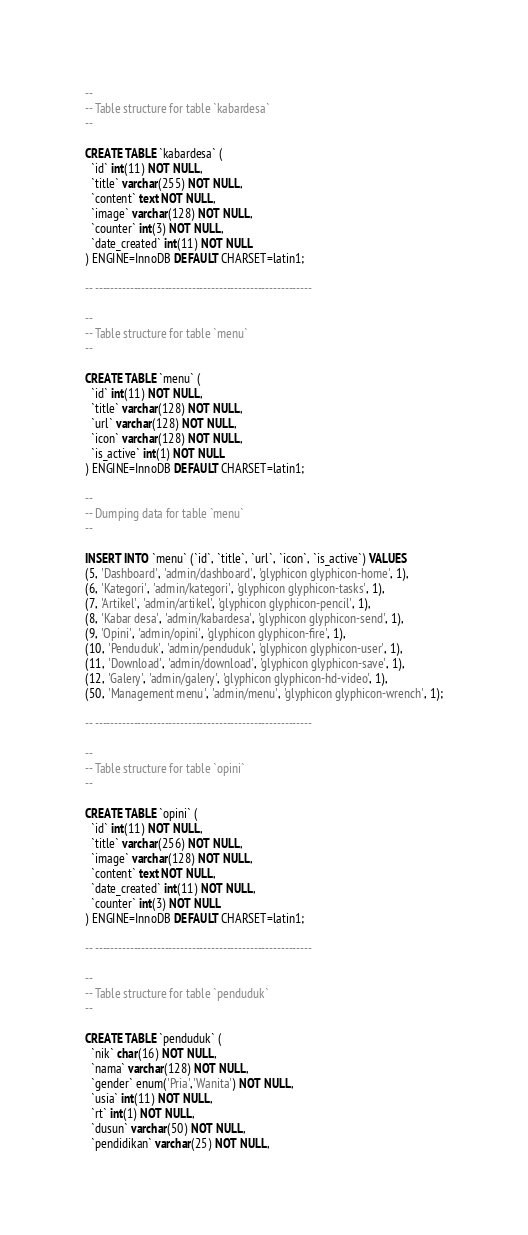<code> <loc_0><loc_0><loc_500><loc_500><_SQL_>
--
-- Table structure for table `kabardesa`
--

CREATE TABLE `kabardesa` (
  `id` int(11) NOT NULL,
  `title` varchar(255) NOT NULL,
  `content` text NOT NULL,
  `image` varchar(128) NOT NULL,
  `counter` int(3) NOT NULL,
  `date_created` int(11) NOT NULL
) ENGINE=InnoDB DEFAULT CHARSET=latin1;

-- --------------------------------------------------------

--
-- Table structure for table `menu`
--

CREATE TABLE `menu` (
  `id` int(11) NOT NULL,
  `title` varchar(128) NOT NULL,
  `url` varchar(128) NOT NULL,
  `icon` varchar(128) NOT NULL,
  `is_active` int(1) NOT NULL
) ENGINE=InnoDB DEFAULT CHARSET=latin1;

--
-- Dumping data for table `menu`
--

INSERT INTO `menu` (`id`, `title`, `url`, `icon`, `is_active`) VALUES
(5, 'Dashboard', 'admin/dashboard', 'glyphicon glyphicon-home', 1),
(6, 'Kategori', 'admin/kategori', 'glyphicon glyphicon-tasks', 1),
(7, 'Artikel', 'admin/artikel', 'glyphicon glyphicon-pencil', 1),
(8, 'Kabar desa', 'admin/kabardesa', 'glyphicon glyphicon-send', 1),
(9, 'Opini', 'admin/opini', 'glyphicon glyphicon-fire', 1),
(10, 'Penduduk', 'admin/penduduk', 'glyphicon glyphicon-user', 1),
(11, 'Download', 'admin/download', 'glyphicon glyphicon-save', 1),
(12, 'Galery', 'admin/galery', 'glyphicon glyphicon-hd-video', 1),
(50, 'Management menu', 'admin/menu', 'glyphicon glyphicon-wrench', 1);

-- --------------------------------------------------------

--
-- Table structure for table `opini`
--

CREATE TABLE `opini` (
  `id` int(11) NOT NULL,
  `title` varchar(256) NOT NULL,
  `image` varchar(128) NOT NULL,
  `content` text NOT NULL,
  `date_created` int(11) NOT NULL,
  `counter` int(3) NOT NULL
) ENGINE=InnoDB DEFAULT CHARSET=latin1;

-- --------------------------------------------------------

--
-- Table structure for table `penduduk`
--

CREATE TABLE `penduduk` (
  `nik` char(16) NOT NULL,
  `nama` varchar(128) NOT NULL,
  `gender` enum('Pria','Wanita') NOT NULL,
  `usia` int(11) NOT NULL,
  `rt` int(1) NOT NULL,
  `dusun` varchar(50) NOT NULL,
  `pendidikan` varchar(25) NOT NULL,</code> 